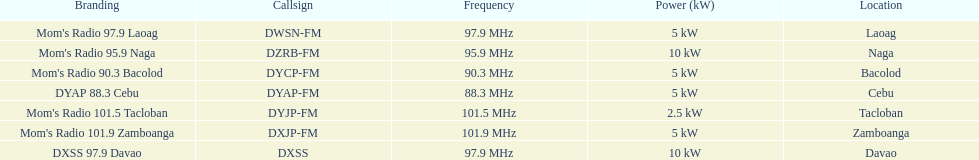What is the final destination indicated on this chart? Davao. 